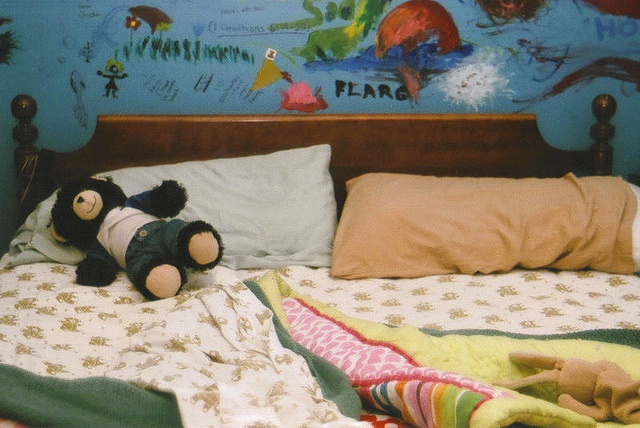Describe the objects in this image and their specific colors. I can see bed in teal, lightgray, black, and tan tones and teddy bear in teal, black, darkgray, and tan tones in this image. 